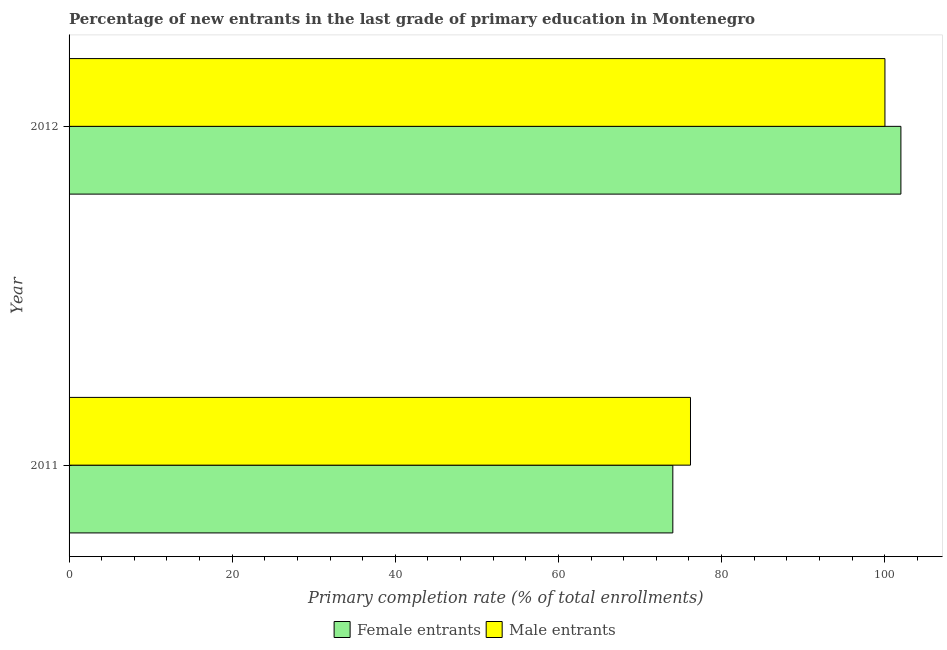How many different coloured bars are there?
Give a very brief answer. 2. How many groups of bars are there?
Provide a short and direct response. 2. Are the number of bars on each tick of the Y-axis equal?
Keep it short and to the point. Yes. How many bars are there on the 1st tick from the top?
Provide a short and direct response. 2. What is the label of the 1st group of bars from the top?
Offer a terse response. 2012. In how many cases, is the number of bars for a given year not equal to the number of legend labels?
Your answer should be compact. 0. What is the primary completion rate of male entrants in 2012?
Your answer should be very brief. 100.02. Across all years, what is the maximum primary completion rate of female entrants?
Offer a terse response. 101.98. Across all years, what is the minimum primary completion rate of male entrants?
Your answer should be compact. 76.18. In which year was the primary completion rate of male entrants maximum?
Provide a short and direct response. 2012. In which year was the primary completion rate of male entrants minimum?
Provide a short and direct response. 2011. What is the total primary completion rate of male entrants in the graph?
Keep it short and to the point. 176.21. What is the difference between the primary completion rate of male entrants in 2011 and that in 2012?
Give a very brief answer. -23.84. What is the difference between the primary completion rate of female entrants in 2012 and the primary completion rate of male entrants in 2011?
Ensure brevity in your answer.  25.8. What is the average primary completion rate of female entrants per year?
Your answer should be very brief. 88. In the year 2012, what is the difference between the primary completion rate of female entrants and primary completion rate of male entrants?
Provide a short and direct response. 1.96. In how many years, is the primary completion rate of female entrants greater than 76 %?
Provide a succinct answer. 1. What is the ratio of the primary completion rate of female entrants in 2011 to that in 2012?
Your answer should be compact. 0.73. Is the primary completion rate of male entrants in 2011 less than that in 2012?
Offer a very short reply. Yes. Is the difference between the primary completion rate of female entrants in 2011 and 2012 greater than the difference between the primary completion rate of male entrants in 2011 and 2012?
Offer a very short reply. No. In how many years, is the primary completion rate of male entrants greater than the average primary completion rate of male entrants taken over all years?
Your answer should be compact. 1. What does the 1st bar from the top in 2011 represents?
Make the answer very short. Male entrants. What does the 2nd bar from the bottom in 2011 represents?
Offer a very short reply. Male entrants. How many bars are there?
Provide a succinct answer. 4. Are all the bars in the graph horizontal?
Your answer should be very brief. Yes. How many years are there in the graph?
Your answer should be compact. 2. What is the difference between two consecutive major ticks on the X-axis?
Provide a succinct answer. 20. Does the graph contain any zero values?
Make the answer very short. No. How many legend labels are there?
Give a very brief answer. 2. How are the legend labels stacked?
Your response must be concise. Horizontal. What is the title of the graph?
Give a very brief answer. Percentage of new entrants in the last grade of primary education in Montenegro. What is the label or title of the X-axis?
Your response must be concise. Primary completion rate (% of total enrollments). What is the Primary completion rate (% of total enrollments) of Female entrants in 2011?
Provide a short and direct response. 74.02. What is the Primary completion rate (% of total enrollments) in Male entrants in 2011?
Offer a very short reply. 76.18. What is the Primary completion rate (% of total enrollments) of Female entrants in 2012?
Provide a succinct answer. 101.98. What is the Primary completion rate (% of total enrollments) in Male entrants in 2012?
Ensure brevity in your answer.  100.02. Across all years, what is the maximum Primary completion rate (% of total enrollments) in Female entrants?
Provide a succinct answer. 101.98. Across all years, what is the maximum Primary completion rate (% of total enrollments) in Male entrants?
Give a very brief answer. 100.02. Across all years, what is the minimum Primary completion rate (% of total enrollments) of Female entrants?
Offer a very short reply. 74.02. Across all years, what is the minimum Primary completion rate (% of total enrollments) of Male entrants?
Give a very brief answer. 76.18. What is the total Primary completion rate (% of total enrollments) in Female entrants in the graph?
Give a very brief answer. 176. What is the total Primary completion rate (% of total enrollments) of Male entrants in the graph?
Your answer should be compact. 176.21. What is the difference between the Primary completion rate (% of total enrollments) of Female entrants in 2011 and that in 2012?
Offer a very short reply. -27.96. What is the difference between the Primary completion rate (% of total enrollments) of Male entrants in 2011 and that in 2012?
Make the answer very short. -23.84. What is the difference between the Primary completion rate (% of total enrollments) of Female entrants in 2011 and the Primary completion rate (% of total enrollments) of Male entrants in 2012?
Your response must be concise. -26. What is the average Primary completion rate (% of total enrollments) in Female entrants per year?
Provide a succinct answer. 88. What is the average Primary completion rate (% of total enrollments) of Male entrants per year?
Your answer should be very brief. 88.1. In the year 2011, what is the difference between the Primary completion rate (% of total enrollments) of Female entrants and Primary completion rate (% of total enrollments) of Male entrants?
Your answer should be very brief. -2.16. In the year 2012, what is the difference between the Primary completion rate (% of total enrollments) in Female entrants and Primary completion rate (% of total enrollments) in Male entrants?
Offer a terse response. 1.96. What is the ratio of the Primary completion rate (% of total enrollments) in Female entrants in 2011 to that in 2012?
Ensure brevity in your answer.  0.73. What is the ratio of the Primary completion rate (% of total enrollments) in Male entrants in 2011 to that in 2012?
Ensure brevity in your answer.  0.76. What is the difference between the highest and the second highest Primary completion rate (% of total enrollments) in Female entrants?
Keep it short and to the point. 27.96. What is the difference between the highest and the second highest Primary completion rate (% of total enrollments) in Male entrants?
Your response must be concise. 23.84. What is the difference between the highest and the lowest Primary completion rate (% of total enrollments) in Female entrants?
Ensure brevity in your answer.  27.96. What is the difference between the highest and the lowest Primary completion rate (% of total enrollments) of Male entrants?
Your answer should be compact. 23.84. 